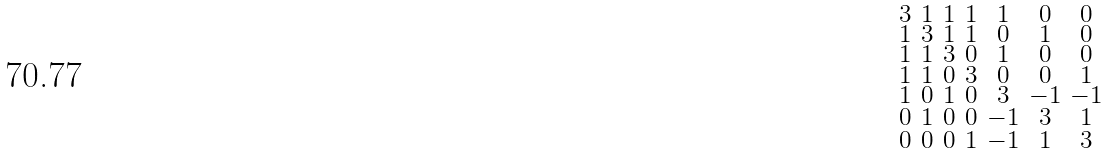<formula> <loc_0><loc_0><loc_500><loc_500>\begin{smallmatrix} 3 & 1 & 1 & 1 & 1 & 0 & 0 \\ 1 & 3 & 1 & 1 & 0 & 1 & 0 \\ 1 & 1 & 3 & 0 & 1 & 0 & 0 \\ 1 & 1 & 0 & 3 & 0 & 0 & 1 \\ 1 & 0 & 1 & 0 & 3 & - 1 & - 1 \\ 0 & 1 & 0 & 0 & - 1 & 3 & 1 \\ 0 & 0 & 0 & 1 & - 1 & 1 & 3 \end{smallmatrix}</formula> 